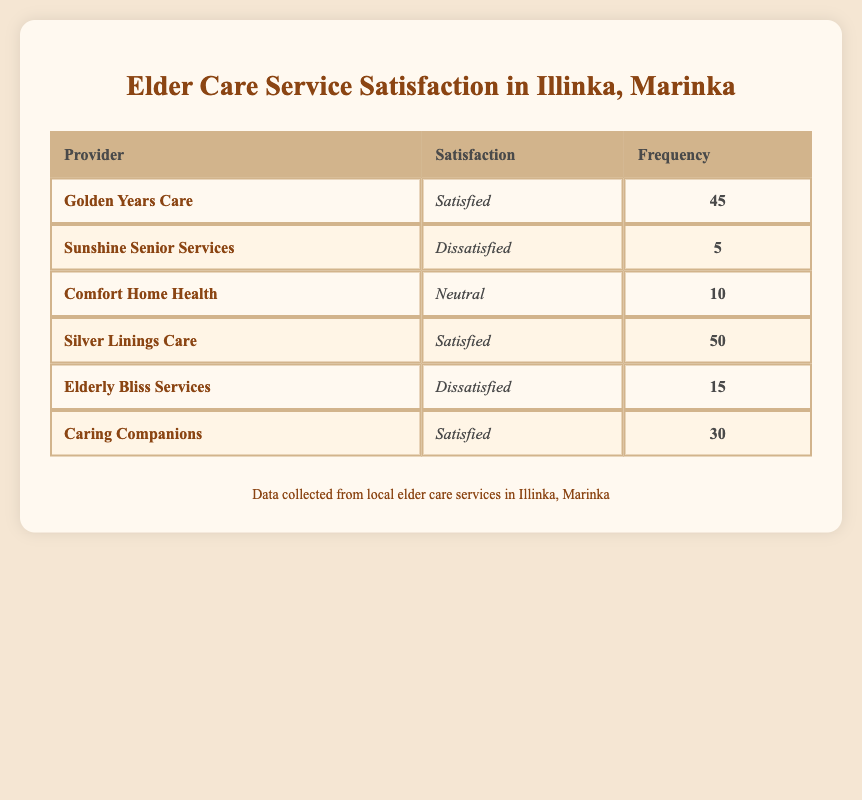What is the satisfaction level for Golden Years Care? The table lists "Golden Years Care" under the Satisfaction column, which shows "Satisfied." Thus, the satisfaction level for this provider is "Satisfied."
Answer: Satisfied What is the total frequency of satisfied responses among all providers? We look for the frequency of each provider that lists "Satisfied" in the Satisfaction column. These are: Golden Years Care (45), Silver Linings Care (50), and Caring Companions (30). Adding these gives us: 45 + 50 + 30 = 125.
Answer: 125 How many providers have a "Dissatisfied" satisfaction level? Checking the Satisfaction column, we find "Dissatisfied" for two providers: Sunshine Senior Services and Elderly Bliss Services. Therefore, there are 2 providers who have this level of satisfaction.
Answer: 2 What is the frequency of the “Neutral” satisfaction level? There is only one provider with a "Neutral" satisfaction level, which is Comfort Home Health, with a frequency of 10. Therefore, the frequency for this level is 10.
Answer: 10 Is Caring Companions more frequently rated as "Satisfied" than Sunshine Senior Services is rated as "Dissatisfied"? Caring Companions has a frequency of 30 for "Satisfied," while Sunshine Senior Services has a frequency of 5 for "Dissatisfied." Since 30 is greater than 5, the statement is true.
Answer: Yes What is the average frequency of the “Dissatisfied” satisfaction level? We have 2 providers with a "Dissatisfied" level: Sunshine Senior Services (5) and Elderly Bliss Services (15). We sum their frequencies: 5 + 15 = 20. To find the average, we divide by the number of providers: 20 / 2 = 10.
Answer: 10 Which provider has the highest frequency for satisfaction? Comparing the frequencies listed, Silver Linings Care has the highest frequency of 50 for "Satisfied." No other provider reaches this number.
Answer: Silver Linings Care How many more satisfied responses does Silver Linings Care have than Golden Years Care? Silver Linings Care has a frequency of 50, while Golden Years Care has a frequency of 45. Subtracting these gives: 50 - 45 = 5. Therefore, Silver Linings Care has 5 more satisfied responses than Golden Years Care.
Answer: 5 